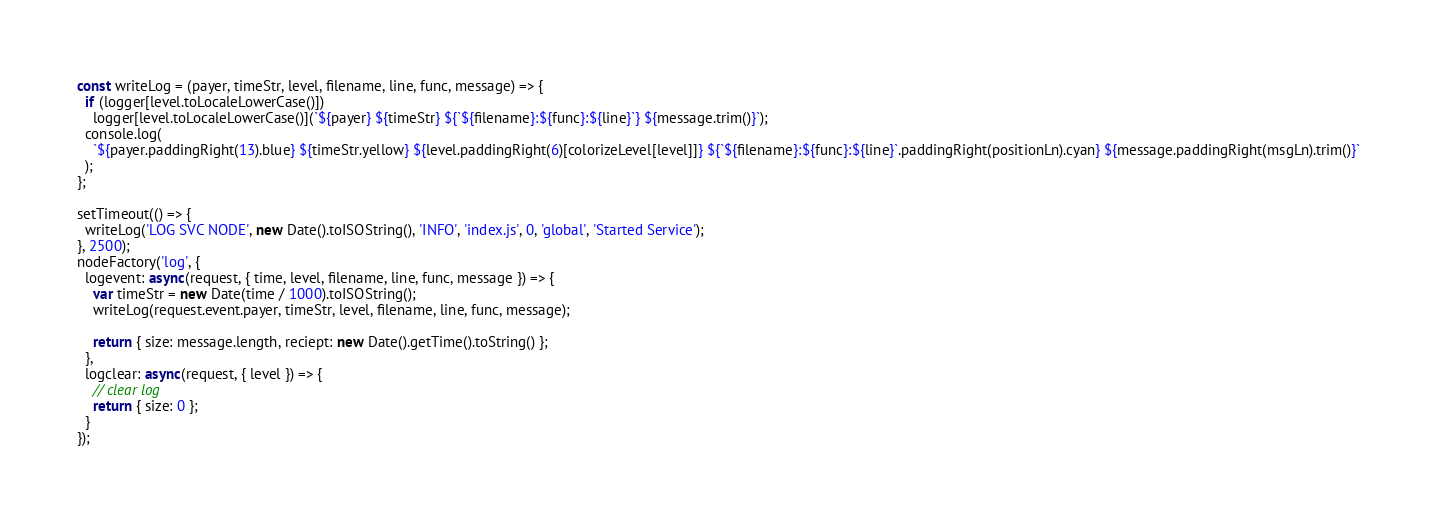<code> <loc_0><loc_0><loc_500><loc_500><_JavaScript_>const writeLog = (payer, timeStr, level, filename, line, func, message) => {
  if (logger[level.toLocaleLowerCase()])
    logger[level.toLocaleLowerCase()](`${payer} ${timeStr} ${`${filename}:${func}:${line}`} ${message.trim()}`);
  console.log(
    `${payer.paddingRight(13).blue} ${timeStr.yellow} ${level.paddingRight(6)[colorizeLevel[level]]} ${`${filename}:${func}:${line}`.paddingRight(positionLn).cyan} ${message.paddingRight(msgLn).trim()}`
  );
};

setTimeout(() => {
  writeLog('LOG SVC NODE', new Date().toISOString(), 'INFO', 'index.js', 0, 'global', 'Started Service');
}, 2500);
nodeFactory('log', {
  logevent: async(request, { time, level, filename, line, func, message }) => {
    var timeStr = new Date(time / 1000).toISOString();
    writeLog(request.event.payer, timeStr, level, filename, line, func, message);

    return { size: message.length, reciept: new Date().getTime().toString() };
  },
  logclear: async(request, { level }) => {
    // clear log
    return { size: 0 };
  }
});
</code> 